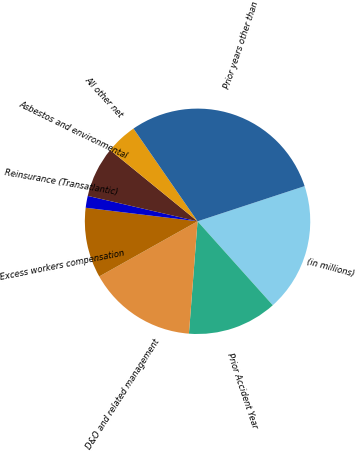<chart> <loc_0><loc_0><loc_500><loc_500><pie_chart><fcel>(in millions)<fcel>Prior Accident Year<fcel>D&O and related management<fcel>Excess workers compensation<fcel>Reinsurance (Transatlantic)<fcel>Asbestos and environmental<fcel>All other net<fcel>Prior years other than<nl><fcel>18.42%<fcel>12.85%<fcel>15.64%<fcel>10.06%<fcel>1.7%<fcel>7.27%<fcel>4.49%<fcel>29.57%<nl></chart> 